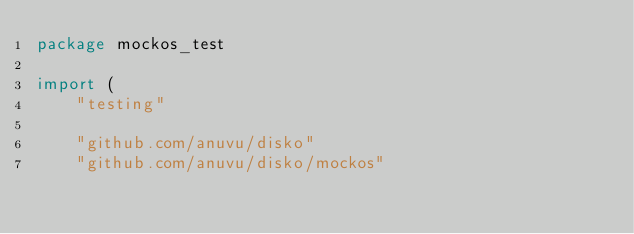Convert code to text. <code><loc_0><loc_0><loc_500><loc_500><_Go_>package mockos_test

import (
	"testing"

	"github.com/anuvu/disko"
	"github.com/anuvu/disko/mockos"</code> 